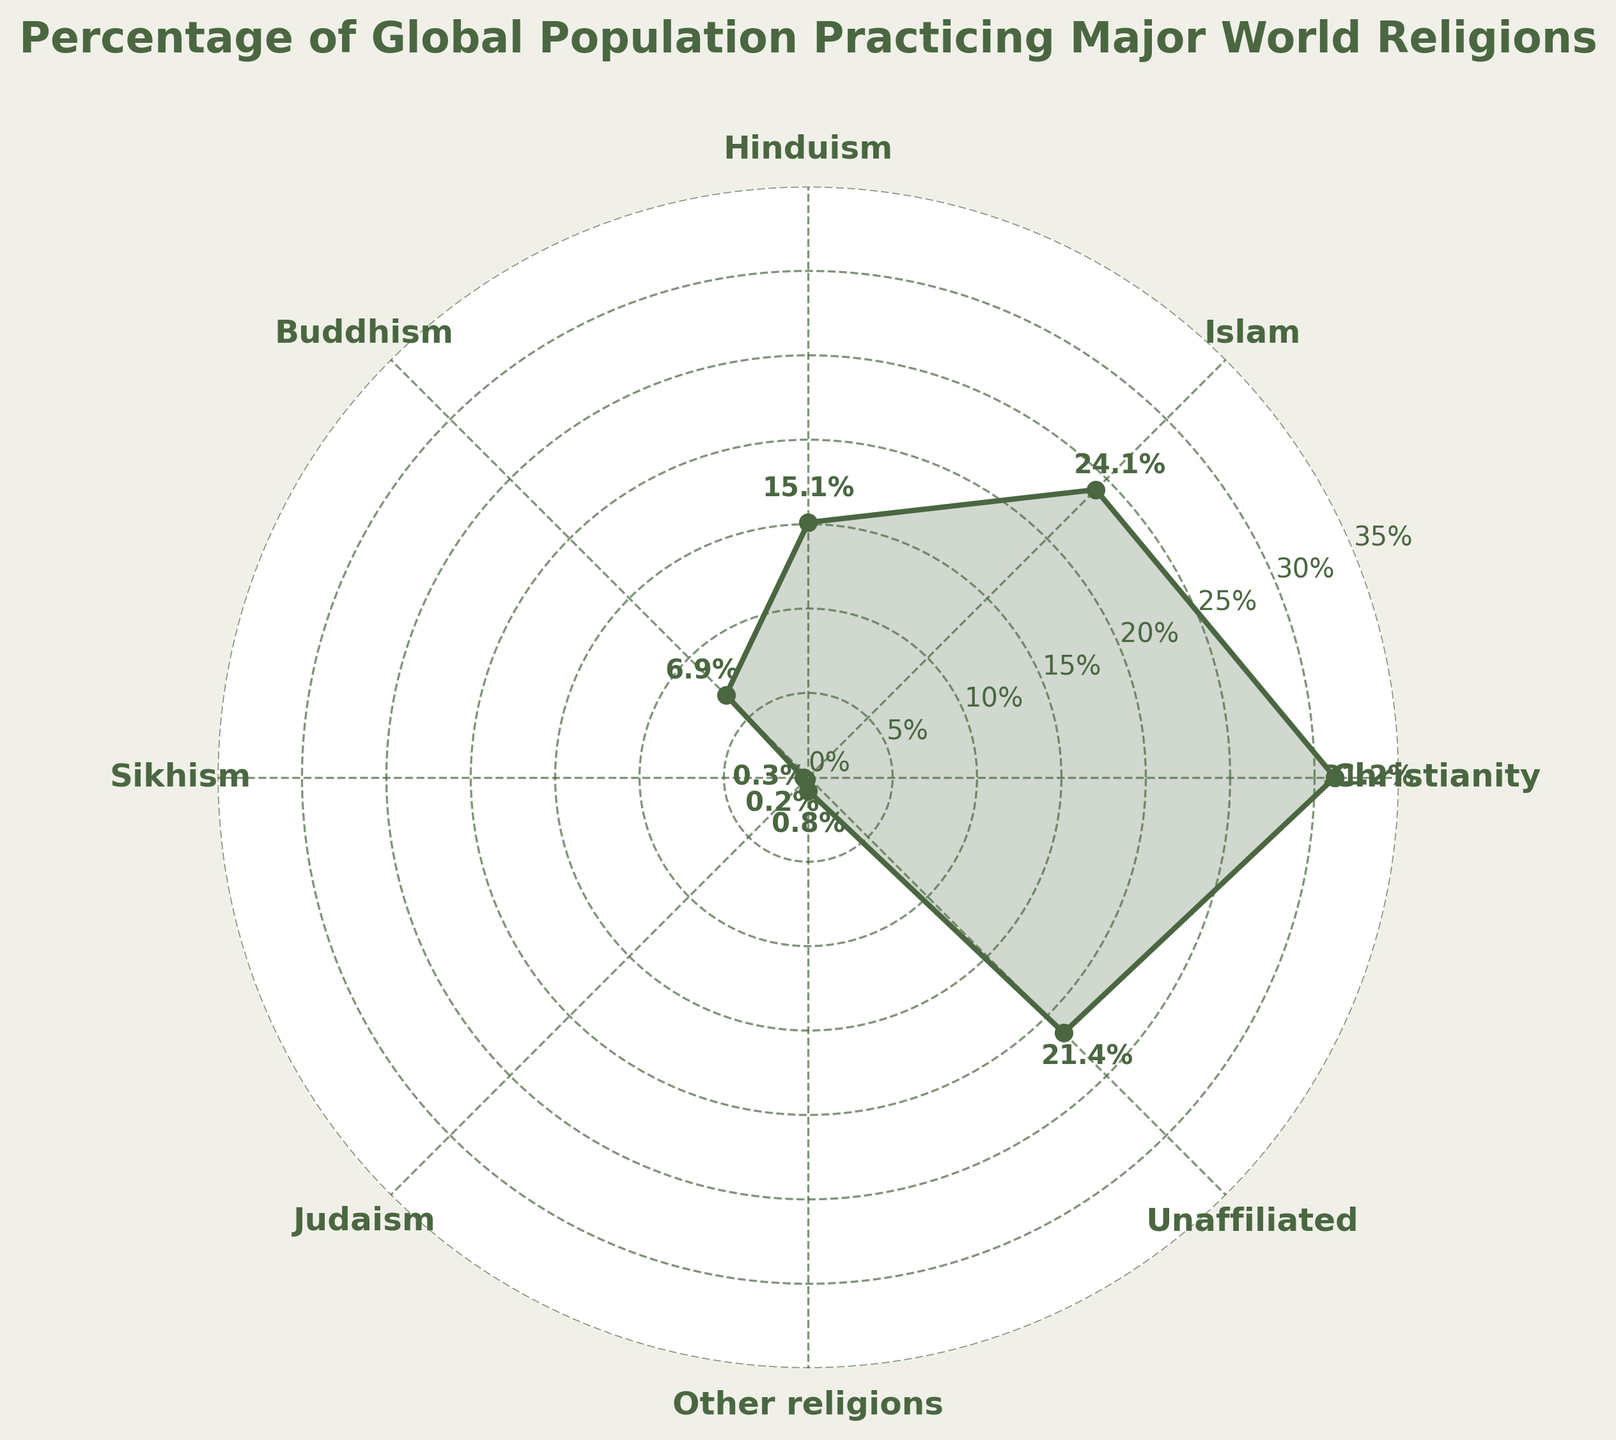What is the title of the chart? The title is typically found at the top of the chart, reading it directly can reveal it.
Answer: Percentage of Global Population Practicing Major World Religions How many religions are displayed on this chart? Counting the number of labels on the outer rim of the chart reveals the number of religions displayed.
Answer: 8 What religion has the highest percentage of followers according to the chart? Locate the highest percentage value on the chart and identify the corresponding religion.
Answer: Christianity Which two religions have the smallest percentages of followers? Identify the two smallest percentage values and their corresponding religions.
Answer: Judaism and Sikhism What is the percentage of people who are unaffiliated with any religion? Find the segment labeled "Unaffiliated" and read its corresponding percentage.
Answer: 21.4% What's the combined percentage of people practicing Buddhism and Hinduism? Add the percentages of Buddhism and Hinduism (6.9% + 15.1%).
Answer: 22.0% How does the percentage of people practicing Islam compare to the percentage of people practicing Christianity? Compare the percentage value of Islam (24.1%) with that of Christianity (31.2%).
Answer: Christianity has a higher percentage What percentage of the global population practices religions other than the major world religions listed? Find the segment labeled "Other religions" and read its corresponding percentage.
Answer: 0.8% How much higher is the percentage of people practicing Christianity compared to those unaffiliated with any religion? Subtract the percentage of Unaffiliated (21.4%) from Christianity's percentage (31.2%).
Answer: 9.8% If you combine the percentages of all non-Abrahamic religions (Hinduism, Buddhism, Sikhism, Other religions), what do you get? Add the percentages of Hinduism, Buddhism, Sikhism, and Other religions (15.1% + 6.9% + 0.3% + 0.8%).
Answer: 23.1% 